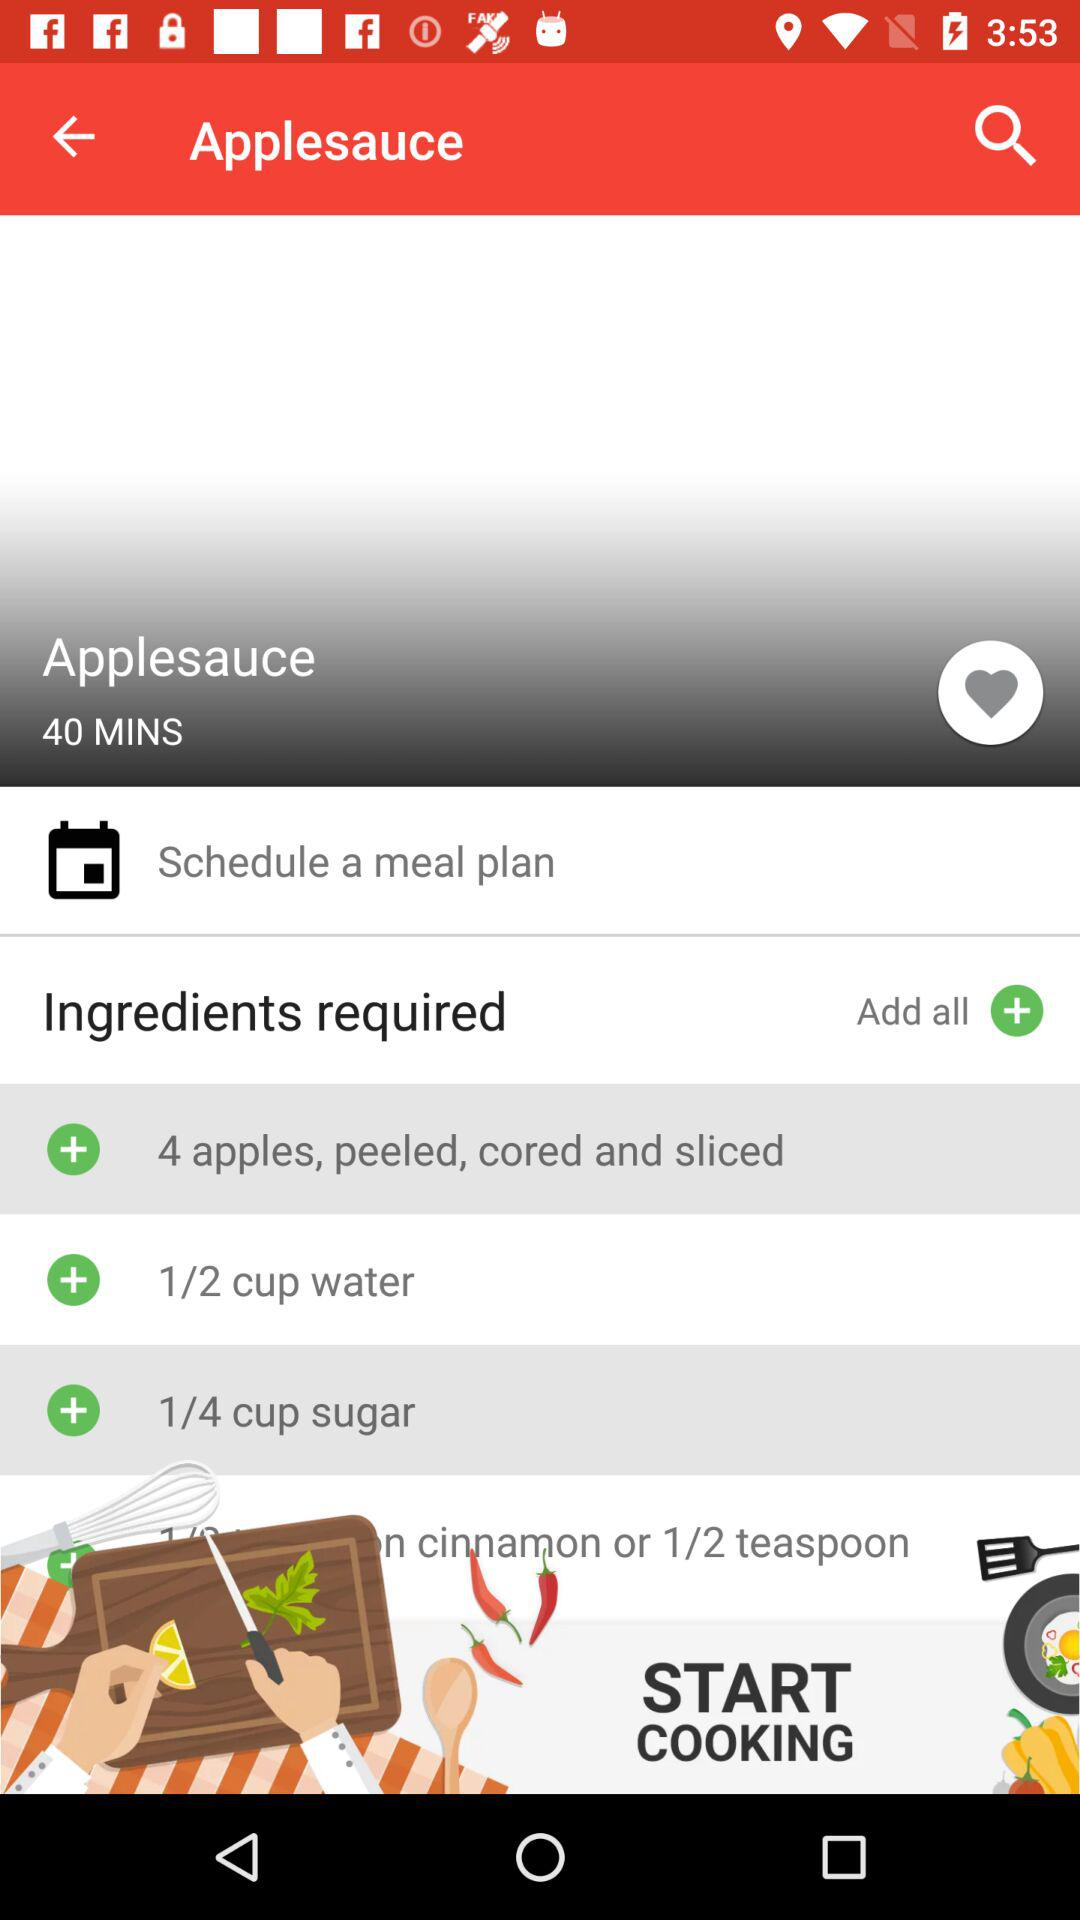Which ingredients are required? The required ingredients are "apples", "water" and "sugar". 